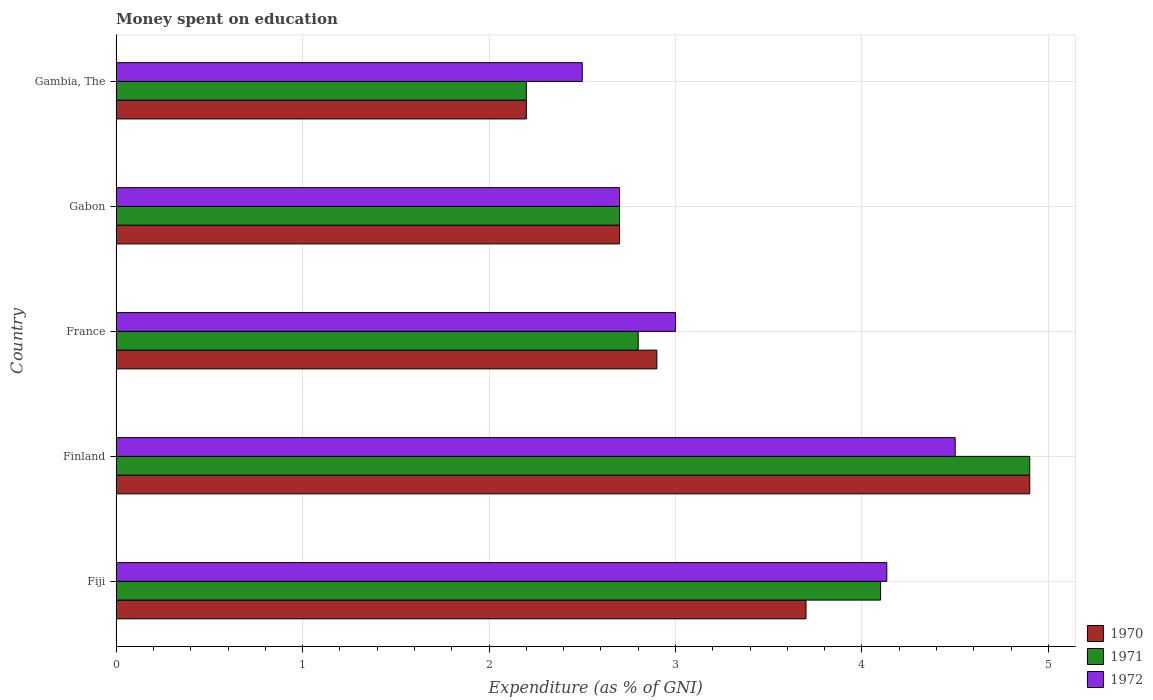How many different coloured bars are there?
Offer a terse response. 3. How many groups of bars are there?
Keep it short and to the point. 5. How many bars are there on the 5th tick from the bottom?
Your answer should be compact. 3. What is the label of the 3rd group of bars from the top?
Provide a succinct answer. France. Across all countries, what is the minimum amount of money spent on education in 1970?
Give a very brief answer. 2.2. In which country was the amount of money spent on education in 1971 minimum?
Your response must be concise. Gambia, The. What is the total amount of money spent on education in 1970 in the graph?
Your answer should be very brief. 16.4. What is the difference between the amount of money spent on education in 1970 in Gabon and that in Gambia, The?
Offer a very short reply. 0.5. What is the difference between the amount of money spent on education in 1972 in Gambia, The and the amount of money spent on education in 1970 in France?
Your response must be concise. -0.4. What is the average amount of money spent on education in 1971 per country?
Keep it short and to the point. 3.34. What is the difference between the amount of money spent on education in 1971 and amount of money spent on education in 1970 in France?
Your response must be concise. -0.1. What is the ratio of the amount of money spent on education in 1970 in Fiji to that in Gambia, The?
Your answer should be compact. 1.68. Is the difference between the amount of money spent on education in 1971 in France and Gambia, The greater than the difference between the amount of money spent on education in 1970 in France and Gambia, The?
Give a very brief answer. No. What is the difference between the highest and the second highest amount of money spent on education in 1972?
Your response must be concise. 0.37. Is it the case that in every country, the sum of the amount of money spent on education in 1970 and amount of money spent on education in 1971 is greater than the amount of money spent on education in 1972?
Give a very brief answer. Yes. What is the difference between two consecutive major ticks on the X-axis?
Keep it short and to the point. 1. Does the graph contain any zero values?
Provide a short and direct response. No. Does the graph contain grids?
Offer a very short reply. Yes. How many legend labels are there?
Offer a very short reply. 3. What is the title of the graph?
Offer a very short reply. Money spent on education. Does "1998" appear as one of the legend labels in the graph?
Provide a succinct answer. No. What is the label or title of the X-axis?
Offer a terse response. Expenditure (as % of GNI). What is the Expenditure (as % of GNI) of 1972 in Fiji?
Ensure brevity in your answer.  4.13. What is the Expenditure (as % of GNI) of 1970 in France?
Your response must be concise. 2.9. What is the Expenditure (as % of GNI) of 1970 in Gabon?
Offer a very short reply. 2.7. What is the Expenditure (as % of GNI) in 1972 in Gambia, The?
Offer a terse response. 2.5. Across all countries, what is the maximum Expenditure (as % of GNI) of 1970?
Make the answer very short. 4.9. Across all countries, what is the minimum Expenditure (as % of GNI) in 1970?
Give a very brief answer. 2.2. Across all countries, what is the minimum Expenditure (as % of GNI) in 1971?
Keep it short and to the point. 2.2. What is the total Expenditure (as % of GNI) in 1970 in the graph?
Make the answer very short. 16.4. What is the total Expenditure (as % of GNI) of 1971 in the graph?
Make the answer very short. 16.7. What is the total Expenditure (as % of GNI) of 1972 in the graph?
Your answer should be very brief. 16.83. What is the difference between the Expenditure (as % of GNI) of 1971 in Fiji and that in Finland?
Make the answer very short. -0.8. What is the difference between the Expenditure (as % of GNI) in 1972 in Fiji and that in Finland?
Keep it short and to the point. -0.37. What is the difference between the Expenditure (as % of GNI) in 1971 in Fiji and that in France?
Offer a very short reply. 1.3. What is the difference between the Expenditure (as % of GNI) in 1972 in Fiji and that in France?
Make the answer very short. 1.13. What is the difference between the Expenditure (as % of GNI) in 1971 in Fiji and that in Gabon?
Provide a succinct answer. 1.4. What is the difference between the Expenditure (as % of GNI) of 1972 in Fiji and that in Gabon?
Keep it short and to the point. 1.43. What is the difference between the Expenditure (as % of GNI) in 1970 in Fiji and that in Gambia, The?
Provide a succinct answer. 1.5. What is the difference between the Expenditure (as % of GNI) of 1972 in Fiji and that in Gambia, The?
Offer a very short reply. 1.63. What is the difference between the Expenditure (as % of GNI) of 1970 in Finland and that in France?
Offer a very short reply. 2. What is the difference between the Expenditure (as % of GNI) of 1971 in Finland and that in France?
Make the answer very short. 2.1. What is the difference between the Expenditure (as % of GNI) of 1972 in Finland and that in France?
Provide a short and direct response. 1.5. What is the difference between the Expenditure (as % of GNI) in 1970 in Finland and that in Gabon?
Your response must be concise. 2.2. What is the difference between the Expenditure (as % of GNI) of 1972 in Finland and that in Gabon?
Your response must be concise. 1.8. What is the difference between the Expenditure (as % of GNI) of 1970 in Finland and that in Gambia, The?
Provide a succinct answer. 2.7. What is the difference between the Expenditure (as % of GNI) in 1971 in Finland and that in Gambia, The?
Offer a terse response. 2.7. What is the difference between the Expenditure (as % of GNI) in 1972 in Finland and that in Gambia, The?
Keep it short and to the point. 2. What is the difference between the Expenditure (as % of GNI) of 1971 in France and that in Gabon?
Your response must be concise. 0.1. What is the difference between the Expenditure (as % of GNI) of 1970 in France and that in Gambia, The?
Ensure brevity in your answer.  0.7. What is the difference between the Expenditure (as % of GNI) of 1970 in Fiji and the Expenditure (as % of GNI) of 1971 in Finland?
Give a very brief answer. -1.2. What is the difference between the Expenditure (as % of GNI) in 1970 in Fiji and the Expenditure (as % of GNI) in 1972 in Finland?
Offer a terse response. -0.8. What is the difference between the Expenditure (as % of GNI) of 1970 in Fiji and the Expenditure (as % of GNI) of 1971 in France?
Your response must be concise. 0.9. What is the difference between the Expenditure (as % of GNI) in 1971 in Fiji and the Expenditure (as % of GNI) in 1972 in France?
Provide a short and direct response. 1.1. What is the difference between the Expenditure (as % of GNI) in 1970 in Fiji and the Expenditure (as % of GNI) in 1971 in Gabon?
Ensure brevity in your answer.  1. What is the difference between the Expenditure (as % of GNI) of 1970 in Fiji and the Expenditure (as % of GNI) of 1971 in Gambia, The?
Your answer should be very brief. 1.5. What is the difference between the Expenditure (as % of GNI) of 1971 in Fiji and the Expenditure (as % of GNI) of 1972 in Gambia, The?
Your response must be concise. 1.6. What is the difference between the Expenditure (as % of GNI) of 1970 in Finland and the Expenditure (as % of GNI) of 1972 in France?
Offer a terse response. 1.9. What is the difference between the Expenditure (as % of GNI) in 1971 in Finland and the Expenditure (as % of GNI) in 1972 in France?
Provide a short and direct response. 1.9. What is the difference between the Expenditure (as % of GNI) of 1970 in Finland and the Expenditure (as % of GNI) of 1971 in Gabon?
Your answer should be compact. 2.2. What is the difference between the Expenditure (as % of GNI) in 1971 in Finland and the Expenditure (as % of GNI) in 1972 in Gabon?
Ensure brevity in your answer.  2.2. What is the difference between the Expenditure (as % of GNI) in 1970 in France and the Expenditure (as % of GNI) in 1971 in Gabon?
Offer a terse response. 0.2. What is the difference between the Expenditure (as % of GNI) in 1970 in France and the Expenditure (as % of GNI) in 1972 in Gabon?
Provide a short and direct response. 0.2. What is the difference between the Expenditure (as % of GNI) of 1970 in France and the Expenditure (as % of GNI) of 1972 in Gambia, The?
Offer a very short reply. 0.4. What is the difference between the Expenditure (as % of GNI) of 1971 in France and the Expenditure (as % of GNI) of 1972 in Gambia, The?
Ensure brevity in your answer.  0.3. What is the difference between the Expenditure (as % of GNI) in 1970 in Gabon and the Expenditure (as % of GNI) in 1971 in Gambia, The?
Give a very brief answer. 0.5. What is the average Expenditure (as % of GNI) in 1970 per country?
Your answer should be compact. 3.28. What is the average Expenditure (as % of GNI) in 1971 per country?
Provide a short and direct response. 3.34. What is the average Expenditure (as % of GNI) in 1972 per country?
Make the answer very short. 3.37. What is the difference between the Expenditure (as % of GNI) in 1970 and Expenditure (as % of GNI) in 1971 in Fiji?
Provide a short and direct response. -0.4. What is the difference between the Expenditure (as % of GNI) in 1970 and Expenditure (as % of GNI) in 1972 in Fiji?
Your answer should be compact. -0.43. What is the difference between the Expenditure (as % of GNI) of 1971 and Expenditure (as % of GNI) of 1972 in Fiji?
Ensure brevity in your answer.  -0.03. What is the difference between the Expenditure (as % of GNI) of 1970 and Expenditure (as % of GNI) of 1971 in Finland?
Provide a short and direct response. 0. What is the difference between the Expenditure (as % of GNI) of 1970 and Expenditure (as % of GNI) of 1972 in Finland?
Ensure brevity in your answer.  0.4. What is the difference between the Expenditure (as % of GNI) of 1971 and Expenditure (as % of GNI) of 1972 in Finland?
Keep it short and to the point. 0.4. What is the difference between the Expenditure (as % of GNI) of 1970 and Expenditure (as % of GNI) of 1971 in France?
Offer a terse response. 0.1. What is the difference between the Expenditure (as % of GNI) in 1971 and Expenditure (as % of GNI) in 1972 in France?
Your response must be concise. -0.2. What is the difference between the Expenditure (as % of GNI) of 1970 and Expenditure (as % of GNI) of 1971 in Gambia, The?
Your response must be concise. 0. What is the ratio of the Expenditure (as % of GNI) in 1970 in Fiji to that in Finland?
Give a very brief answer. 0.76. What is the ratio of the Expenditure (as % of GNI) of 1971 in Fiji to that in Finland?
Your answer should be compact. 0.84. What is the ratio of the Expenditure (as % of GNI) in 1972 in Fiji to that in Finland?
Offer a very short reply. 0.92. What is the ratio of the Expenditure (as % of GNI) in 1970 in Fiji to that in France?
Provide a short and direct response. 1.28. What is the ratio of the Expenditure (as % of GNI) of 1971 in Fiji to that in France?
Provide a succinct answer. 1.46. What is the ratio of the Expenditure (as % of GNI) in 1972 in Fiji to that in France?
Your response must be concise. 1.38. What is the ratio of the Expenditure (as % of GNI) of 1970 in Fiji to that in Gabon?
Ensure brevity in your answer.  1.37. What is the ratio of the Expenditure (as % of GNI) of 1971 in Fiji to that in Gabon?
Keep it short and to the point. 1.52. What is the ratio of the Expenditure (as % of GNI) of 1972 in Fiji to that in Gabon?
Give a very brief answer. 1.53. What is the ratio of the Expenditure (as % of GNI) in 1970 in Fiji to that in Gambia, The?
Your answer should be very brief. 1.68. What is the ratio of the Expenditure (as % of GNI) of 1971 in Fiji to that in Gambia, The?
Make the answer very short. 1.86. What is the ratio of the Expenditure (as % of GNI) of 1972 in Fiji to that in Gambia, The?
Your response must be concise. 1.65. What is the ratio of the Expenditure (as % of GNI) of 1970 in Finland to that in France?
Your answer should be compact. 1.69. What is the ratio of the Expenditure (as % of GNI) in 1972 in Finland to that in France?
Provide a short and direct response. 1.5. What is the ratio of the Expenditure (as % of GNI) in 1970 in Finland to that in Gabon?
Keep it short and to the point. 1.81. What is the ratio of the Expenditure (as % of GNI) in 1971 in Finland to that in Gabon?
Your response must be concise. 1.81. What is the ratio of the Expenditure (as % of GNI) of 1972 in Finland to that in Gabon?
Offer a very short reply. 1.67. What is the ratio of the Expenditure (as % of GNI) in 1970 in Finland to that in Gambia, The?
Provide a short and direct response. 2.23. What is the ratio of the Expenditure (as % of GNI) of 1971 in Finland to that in Gambia, The?
Keep it short and to the point. 2.23. What is the ratio of the Expenditure (as % of GNI) of 1972 in Finland to that in Gambia, The?
Provide a short and direct response. 1.8. What is the ratio of the Expenditure (as % of GNI) in 1970 in France to that in Gabon?
Ensure brevity in your answer.  1.07. What is the ratio of the Expenditure (as % of GNI) in 1971 in France to that in Gabon?
Keep it short and to the point. 1.04. What is the ratio of the Expenditure (as % of GNI) in 1972 in France to that in Gabon?
Offer a very short reply. 1.11. What is the ratio of the Expenditure (as % of GNI) in 1970 in France to that in Gambia, The?
Give a very brief answer. 1.32. What is the ratio of the Expenditure (as % of GNI) of 1971 in France to that in Gambia, The?
Keep it short and to the point. 1.27. What is the ratio of the Expenditure (as % of GNI) of 1972 in France to that in Gambia, The?
Give a very brief answer. 1.2. What is the ratio of the Expenditure (as % of GNI) of 1970 in Gabon to that in Gambia, The?
Make the answer very short. 1.23. What is the ratio of the Expenditure (as % of GNI) of 1971 in Gabon to that in Gambia, The?
Offer a terse response. 1.23. What is the difference between the highest and the second highest Expenditure (as % of GNI) in 1970?
Offer a terse response. 1.2. What is the difference between the highest and the second highest Expenditure (as % of GNI) of 1972?
Give a very brief answer. 0.37. What is the difference between the highest and the lowest Expenditure (as % of GNI) in 1970?
Make the answer very short. 2.7. What is the difference between the highest and the lowest Expenditure (as % of GNI) in 1972?
Provide a short and direct response. 2. 